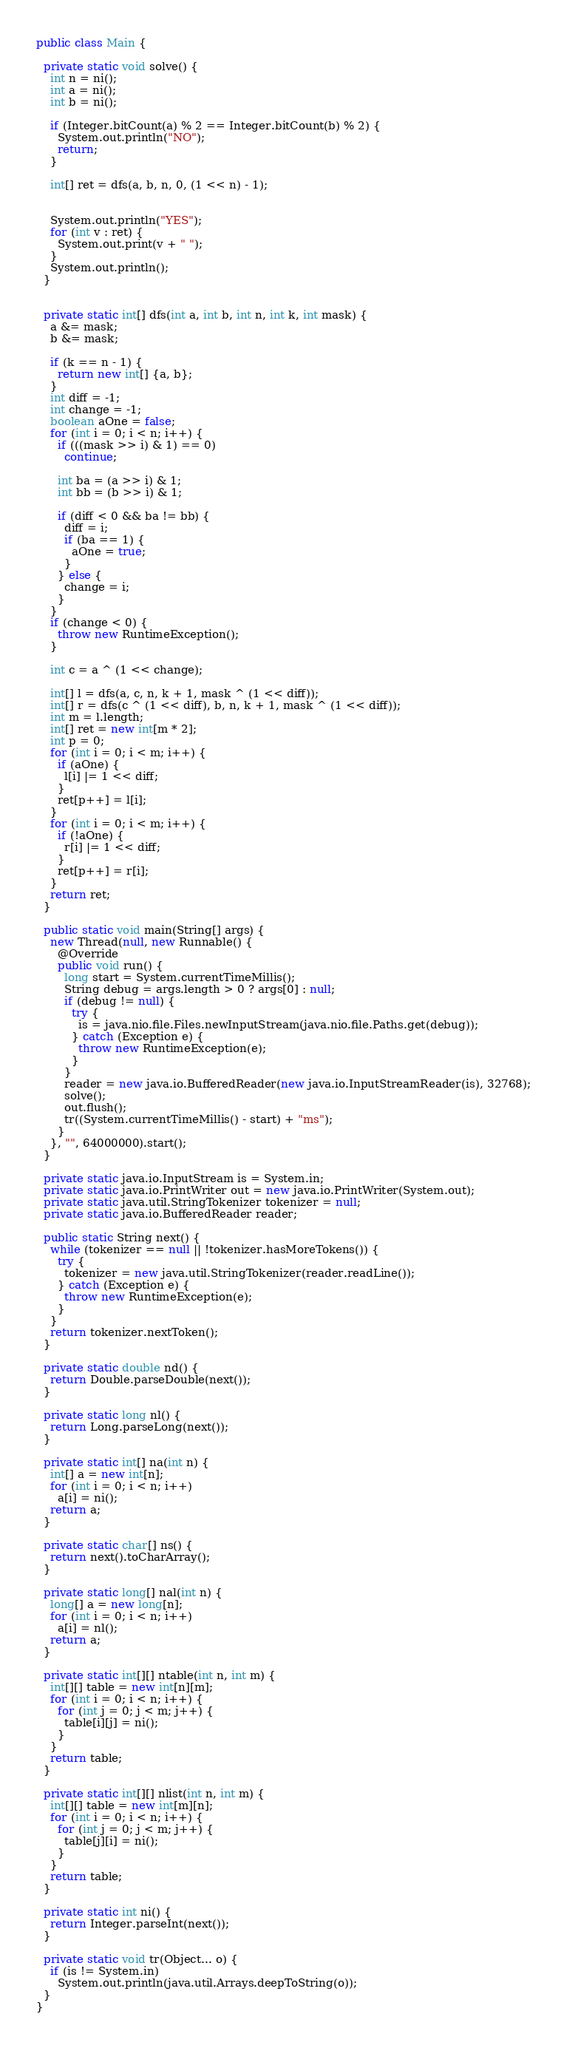<code> <loc_0><loc_0><loc_500><loc_500><_Java_>
public class Main {

  private static void solve() {
    int n = ni();
    int a = ni();
    int b = ni();

    if (Integer.bitCount(a) % 2 == Integer.bitCount(b) % 2) {
      System.out.println("NO");
      return;
    }

    int[] ret = dfs(a, b, n, 0, (1 << n) - 1);


    System.out.println("YES");
    for (int v : ret) {
      System.out.print(v + " ");
    }
    System.out.println();
  }


  private static int[] dfs(int a, int b, int n, int k, int mask) {
    a &= mask;
    b &= mask;

    if (k == n - 1) {
      return new int[] {a, b};
    }
    int diff = -1;
    int change = -1;
    boolean aOne = false;
    for (int i = 0; i < n; i++) {
      if (((mask >> i) & 1) == 0)
        continue;

      int ba = (a >> i) & 1;
      int bb = (b >> i) & 1;

      if (diff < 0 && ba != bb) {
        diff = i;
        if (ba == 1) {
          aOne = true;
        }
      } else {
        change = i;
      }
    }
    if (change < 0) {
      throw new RuntimeException();
    }

    int c = a ^ (1 << change);

    int[] l = dfs(a, c, n, k + 1, mask ^ (1 << diff));
    int[] r = dfs(c ^ (1 << diff), b, n, k + 1, mask ^ (1 << diff));
    int m = l.length;
    int[] ret = new int[m * 2];
    int p = 0;
    for (int i = 0; i < m; i++) {
      if (aOne) {
        l[i] |= 1 << diff;
      }
      ret[p++] = l[i];
    }
    for (int i = 0; i < m; i++) {
      if (!aOne) {
        r[i] |= 1 << diff;
      }
      ret[p++] = r[i];
    }
    return ret;
  }

  public static void main(String[] args) {
    new Thread(null, new Runnable() {
      @Override
      public void run() {
        long start = System.currentTimeMillis();
        String debug = args.length > 0 ? args[0] : null;
        if (debug != null) {
          try {
            is = java.nio.file.Files.newInputStream(java.nio.file.Paths.get(debug));
          } catch (Exception e) {
            throw new RuntimeException(e);
          }
        }
        reader = new java.io.BufferedReader(new java.io.InputStreamReader(is), 32768);
        solve();
        out.flush();
        tr((System.currentTimeMillis() - start) + "ms");
      }
    }, "", 64000000).start();
  }

  private static java.io.InputStream is = System.in;
  private static java.io.PrintWriter out = new java.io.PrintWriter(System.out);
  private static java.util.StringTokenizer tokenizer = null;
  private static java.io.BufferedReader reader;

  public static String next() {
    while (tokenizer == null || !tokenizer.hasMoreTokens()) {
      try {
        tokenizer = new java.util.StringTokenizer(reader.readLine());
      } catch (Exception e) {
        throw new RuntimeException(e);
      }
    }
    return tokenizer.nextToken();
  }

  private static double nd() {
    return Double.parseDouble(next());
  }

  private static long nl() {
    return Long.parseLong(next());
  }

  private static int[] na(int n) {
    int[] a = new int[n];
    for (int i = 0; i < n; i++)
      a[i] = ni();
    return a;
  }

  private static char[] ns() {
    return next().toCharArray();
  }

  private static long[] nal(int n) {
    long[] a = new long[n];
    for (int i = 0; i < n; i++)
      a[i] = nl();
    return a;
  }

  private static int[][] ntable(int n, int m) {
    int[][] table = new int[n][m];
    for (int i = 0; i < n; i++) {
      for (int j = 0; j < m; j++) {
        table[i][j] = ni();
      }
    }
    return table;
  }

  private static int[][] nlist(int n, int m) {
    int[][] table = new int[m][n];
    for (int i = 0; i < n; i++) {
      for (int j = 0; j < m; j++) {
        table[j][i] = ni();
      }
    }
    return table;
  }

  private static int ni() {
    return Integer.parseInt(next());
  }

  private static void tr(Object... o) {
    if (is != System.in)
      System.out.println(java.util.Arrays.deepToString(o));
  }
}

</code> 